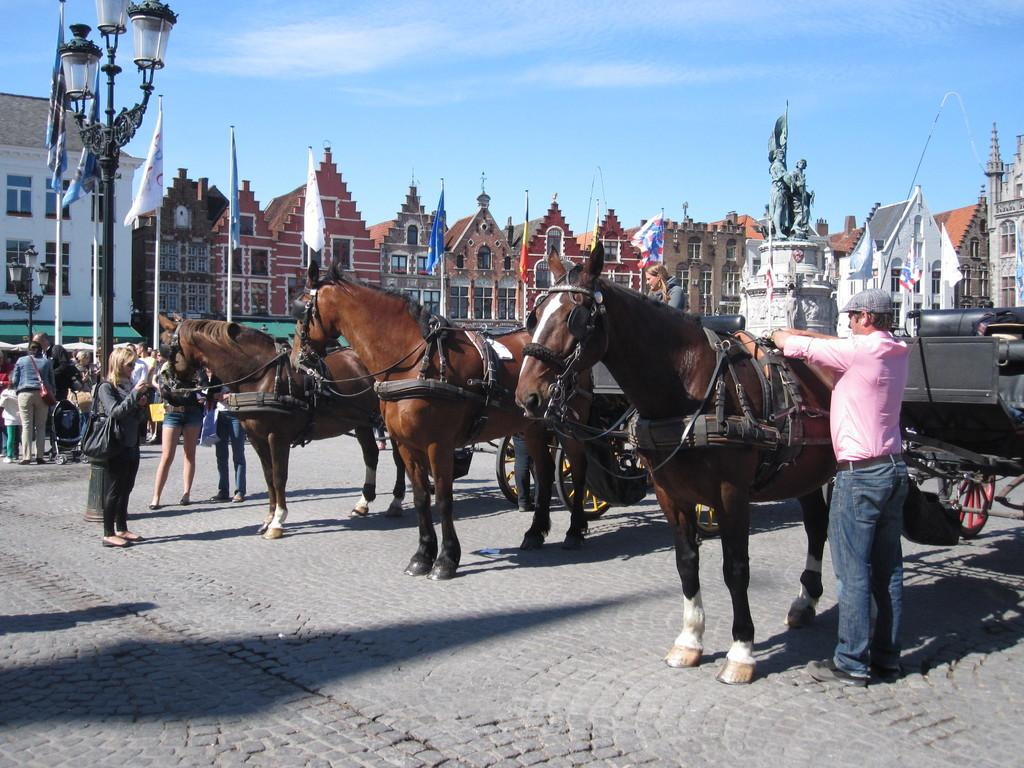What type of vehicles are present in the image? There are horse carts in the image. Who or what can be seen in the image besides the horse carts? There are people in the image. What are the poles used for in the image? The poles are used to hold flags in the image. What can be seen in the background of the image? There are buildings and the sky visible in the background of the image. What type of drum is being played by the people in the image? There is no drum present in the image; it features horse carts, people, poles, flags, buildings, and the sky. 